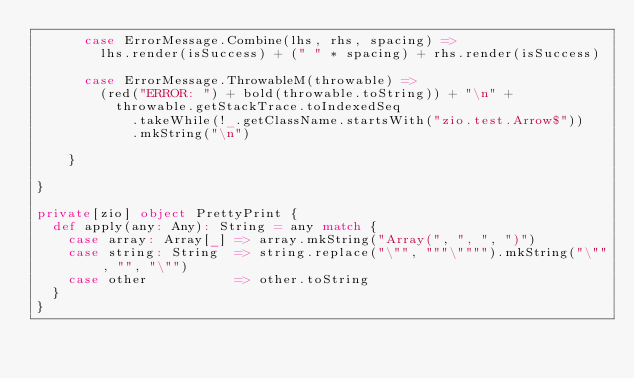Convert code to text. <code><loc_0><loc_0><loc_500><loc_500><_Scala_>      case ErrorMessage.Combine(lhs, rhs, spacing) =>
        lhs.render(isSuccess) + (" " * spacing) + rhs.render(isSuccess)

      case ErrorMessage.ThrowableM(throwable) =>
        (red("ERROR: ") + bold(throwable.toString)) + "\n" +
          throwable.getStackTrace.toIndexedSeq
            .takeWhile(!_.getClassName.startsWith("zio.test.Arrow$"))
            .mkString("\n")

    }

}

private[zio] object PrettyPrint {
  def apply(any: Any): String = any match {
    case array: Array[_] => array.mkString("Array(", ", ", ")")
    case string: String  => string.replace("\"", """\"""").mkString("\"", "", "\"")
    case other           => other.toString
  }
}
</code> 